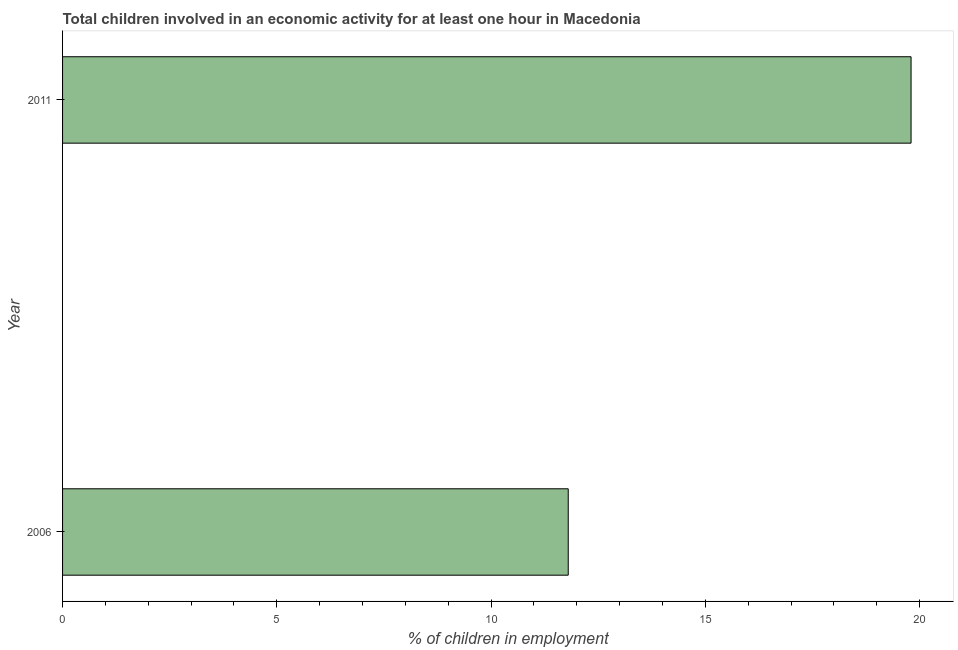Does the graph contain any zero values?
Ensure brevity in your answer.  No. Does the graph contain grids?
Offer a very short reply. No. What is the title of the graph?
Your answer should be compact. Total children involved in an economic activity for at least one hour in Macedonia. What is the label or title of the X-axis?
Your answer should be very brief. % of children in employment. What is the label or title of the Y-axis?
Keep it short and to the point. Year. What is the percentage of children in employment in 2011?
Give a very brief answer. 19.8. Across all years, what is the maximum percentage of children in employment?
Your answer should be compact. 19.8. Across all years, what is the minimum percentage of children in employment?
Your response must be concise. 11.8. In which year was the percentage of children in employment minimum?
Provide a succinct answer. 2006. What is the sum of the percentage of children in employment?
Provide a short and direct response. 31.6. What is the difference between the percentage of children in employment in 2006 and 2011?
Provide a succinct answer. -8. What is the average percentage of children in employment per year?
Provide a succinct answer. 15.8. What is the median percentage of children in employment?
Offer a very short reply. 15.8. Do a majority of the years between 2006 and 2011 (inclusive) have percentage of children in employment greater than 1 %?
Offer a terse response. Yes. What is the ratio of the percentage of children in employment in 2006 to that in 2011?
Make the answer very short. 0.6. Is the percentage of children in employment in 2006 less than that in 2011?
Ensure brevity in your answer.  Yes. In how many years, is the percentage of children in employment greater than the average percentage of children in employment taken over all years?
Ensure brevity in your answer.  1. How many bars are there?
Give a very brief answer. 2. Are all the bars in the graph horizontal?
Your answer should be very brief. Yes. How many years are there in the graph?
Give a very brief answer. 2. What is the difference between two consecutive major ticks on the X-axis?
Your response must be concise. 5. What is the % of children in employment of 2006?
Your answer should be very brief. 11.8. What is the % of children in employment in 2011?
Your answer should be compact. 19.8. What is the ratio of the % of children in employment in 2006 to that in 2011?
Your response must be concise. 0.6. 